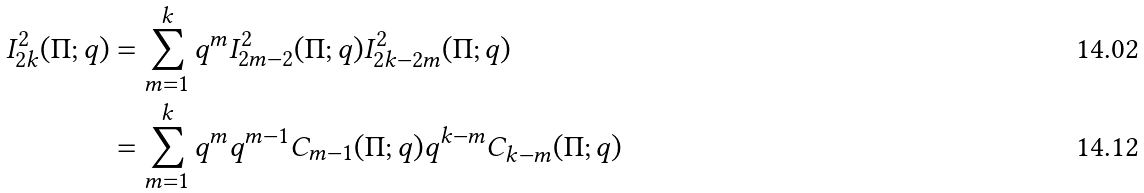<formula> <loc_0><loc_0><loc_500><loc_500>I _ { 2 k } ^ { 2 } ( \Pi ; q ) & = \sum _ { m = 1 } ^ { k } q ^ { m } I _ { 2 m - 2 } ^ { 2 } ( \Pi ; q ) I _ { 2 k - 2 m } ^ { 2 } ( \Pi ; q ) \\ & = \sum _ { m = 1 } ^ { k } q ^ { m } q ^ { m - 1 } C _ { m - 1 } ( \Pi ; q ) q ^ { k - m } C _ { k - m } ( \Pi ; q )</formula> 